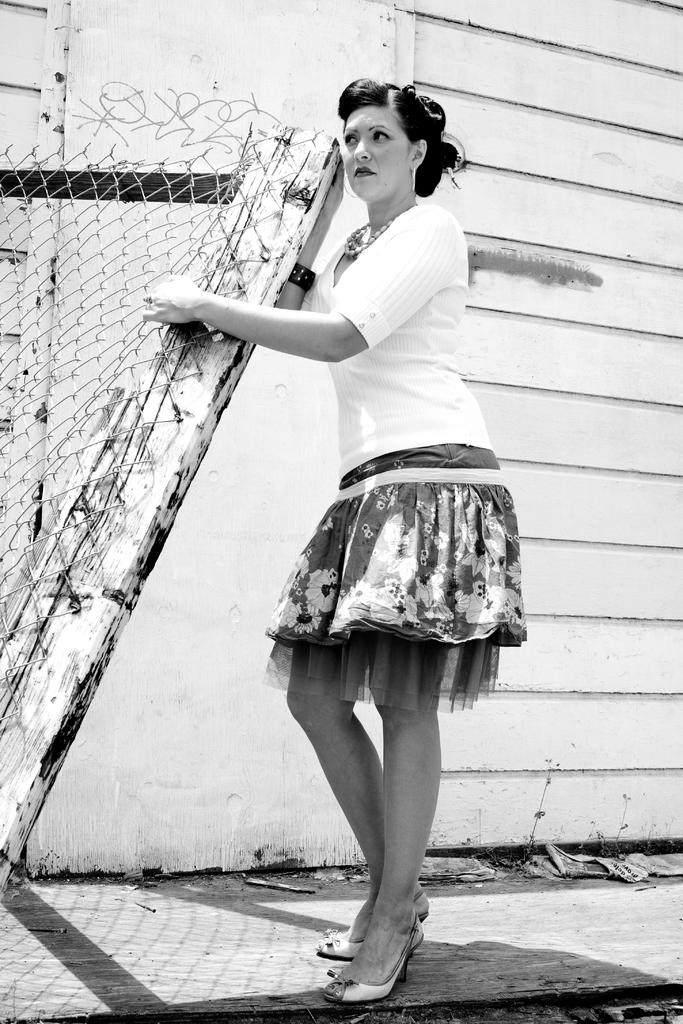What is the main subject of the image? The main subject of the image is a woman. What type of clothing is the woman wearing? The woman is wearing a shirt, shorts, and shoes. Are there any accessories visible in the image? Yes, the woman is wearing a necklace and earrings. What can be seen in the background of the image? There is a wooden wall in the background of the image. Where is the woman standing in the image? The woman is standing near a fence. What type of loaf is the woman holding in the image? There is no loaf present in the image. Can you describe the type of beef that the woman is preparing in the image? There is no beef or any food preparation visible in the image. 